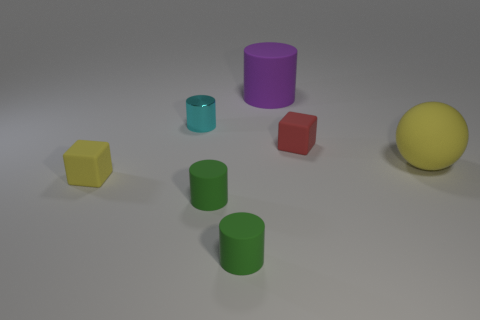Subtract all rubber cylinders. How many cylinders are left? 1 Subtract all balls. How many objects are left? 6 Subtract 1 balls. How many balls are left? 0 Add 7 purple cylinders. How many purple cylinders are left? 8 Add 5 small yellow matte cubes. How many small yellow matte cubes exist? 6 Add 3 big yellow balls. How many objects exist? 10 Subtract all green cylinders. How many cylinders are left? 2 Subtract 1 green cylinders. How many objects are left? 6 Subtract all purple cylinders. Subtract all cyan spheres. How many cylinders are left? 3 Subtract all brown cylinders. How many blue balls are left? 0 